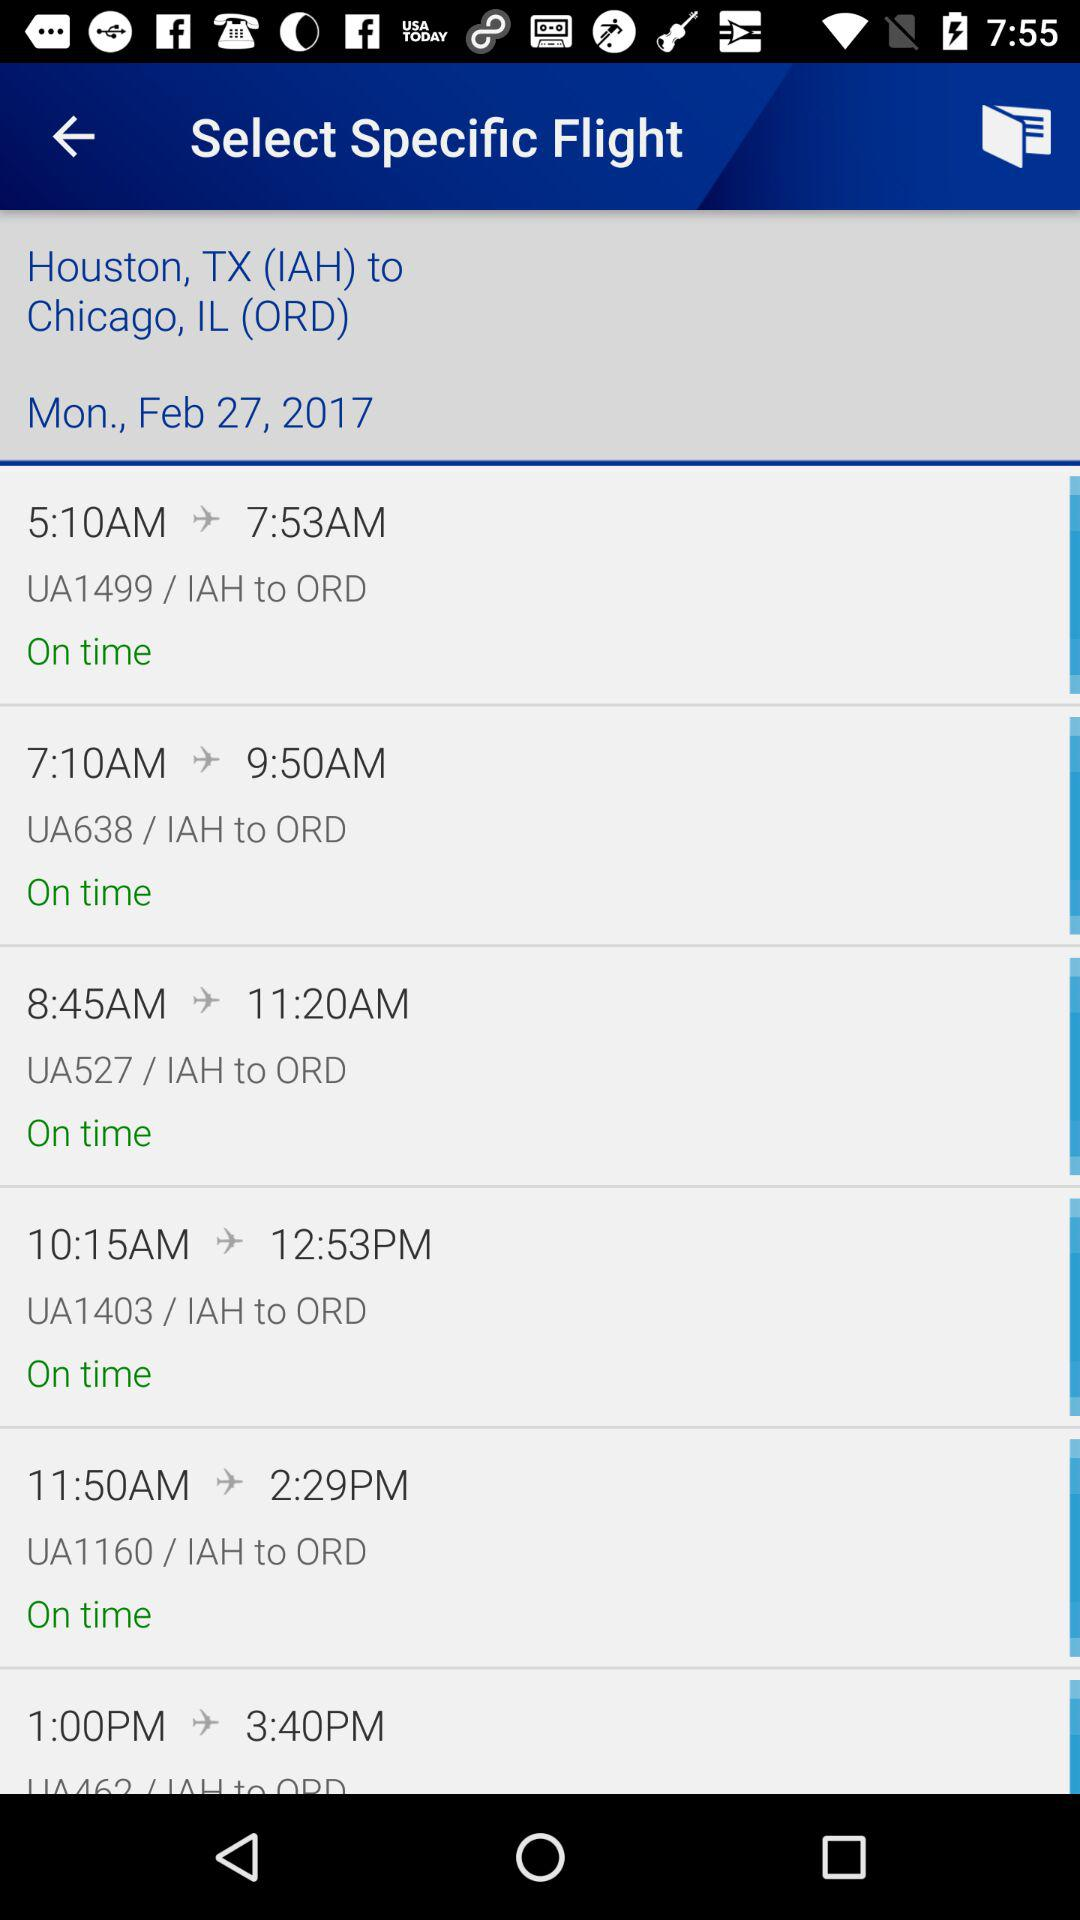What is the flight's destination point? The flight's destination point is Chicago, IL (ORD). 